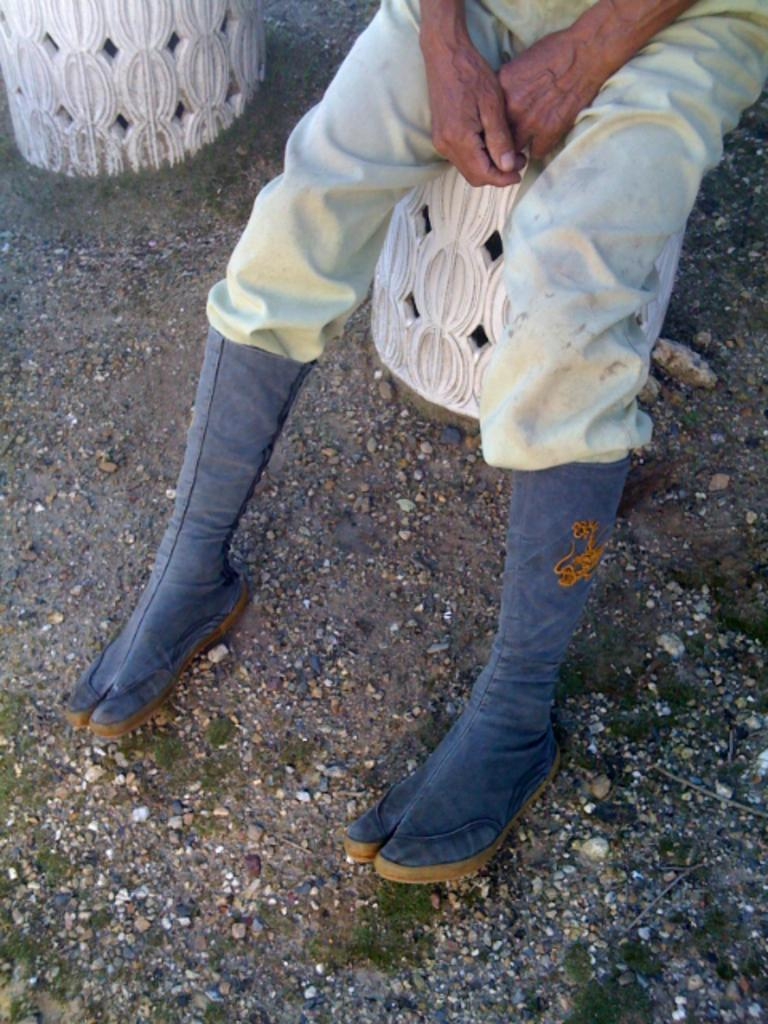What is the person in the image doing? There is a person sitting in the image. What type of footwear is the person wearing? The person is wearing boots. What type of terrain is visible in the image? Grass is present on the ground in the image. Where is the toothbrush located in the image? There is no toothbrush present in the image. 